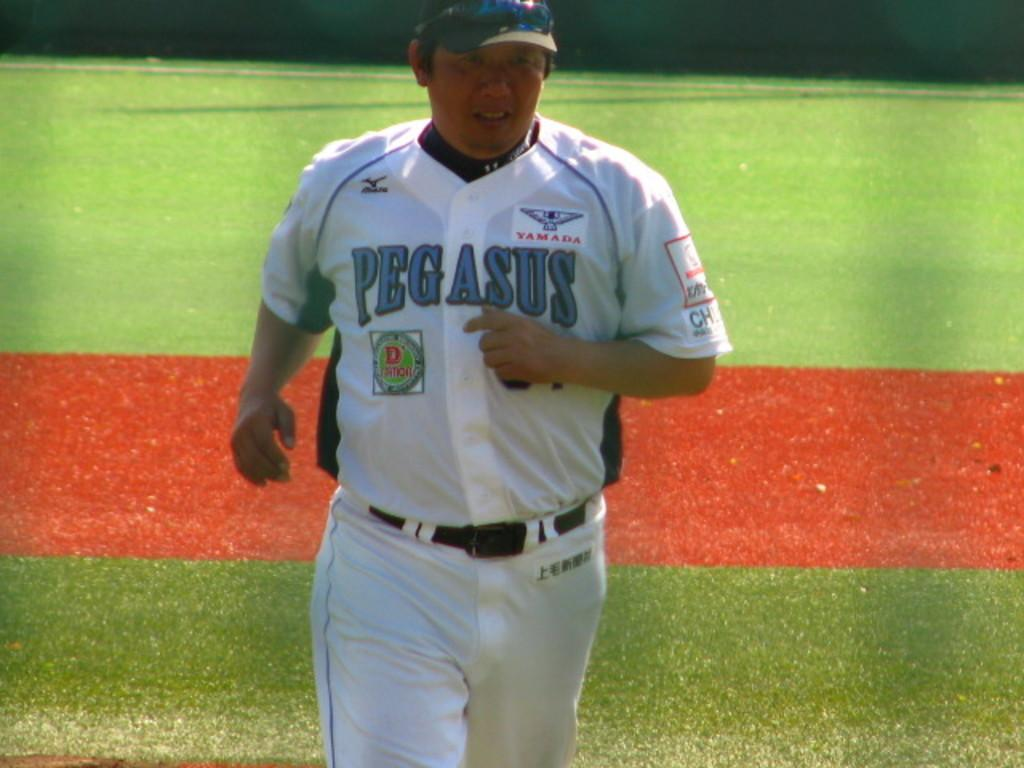<image>
Summarize the visual content of the image. a baseball player with a grey uniform that has the word pegasus on his chest. 